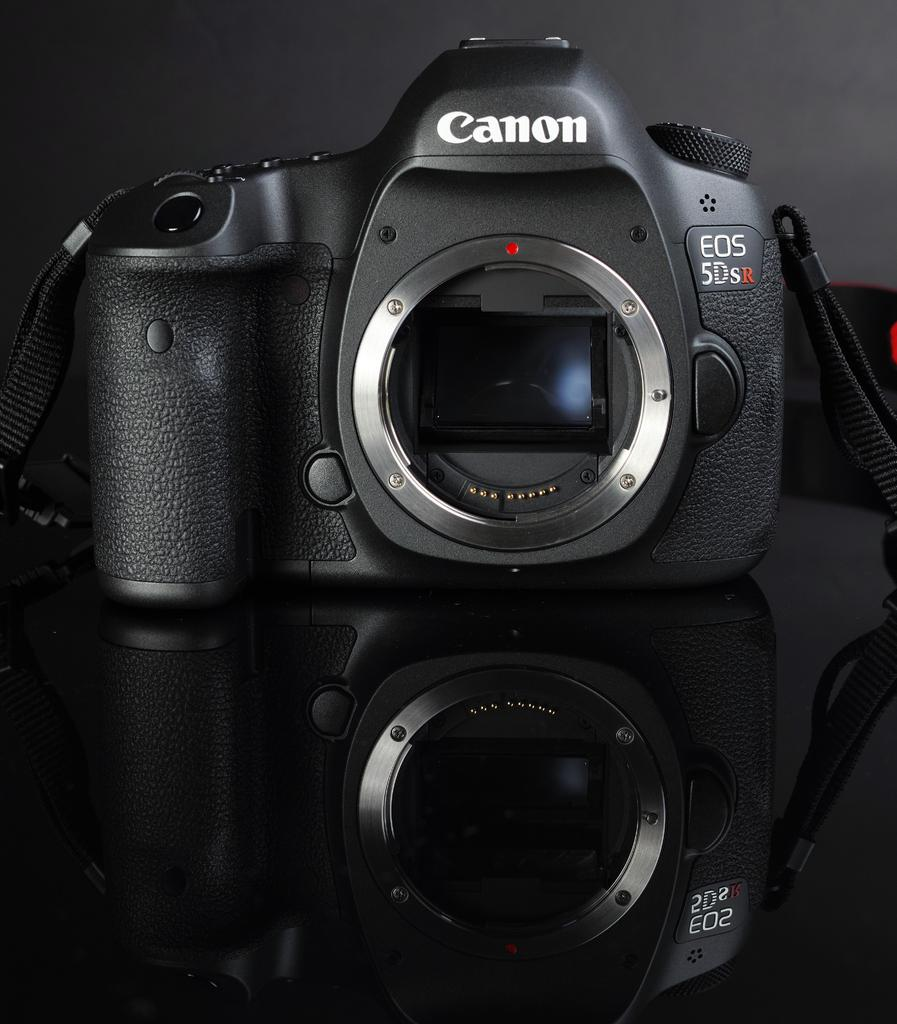<image>
Share a concise interpretation of the image provided. A black Canon EOS 5DSR camera with lens cap off. 